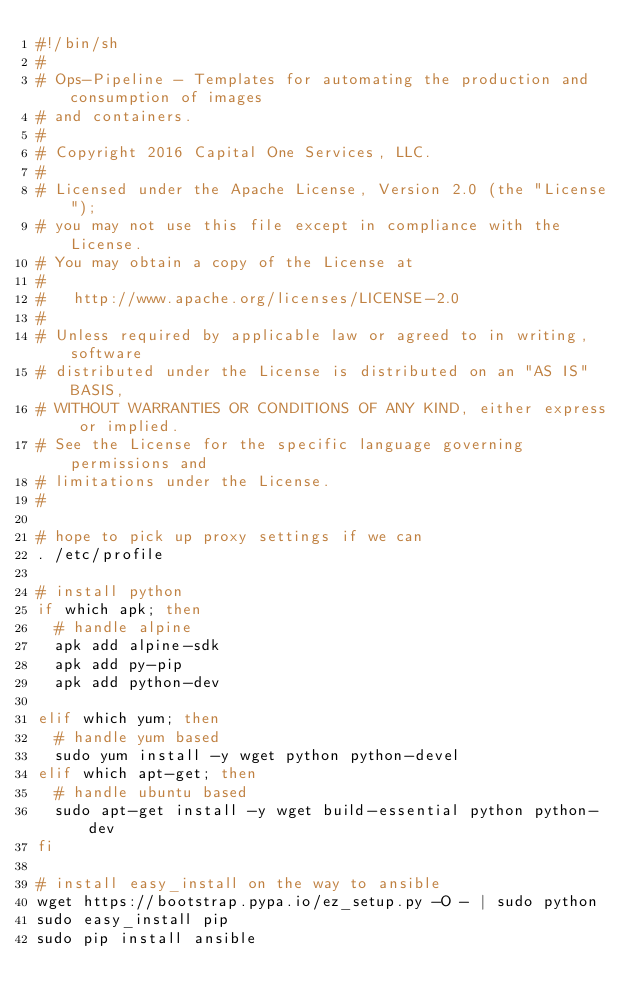<code> <loc_0><loc_0><loc_500><loc_500><_Bash_>#!/bin/sh
#
# Ops-Pipeline - Templates for automating the production and consumption of images
# and containers.
#
# Copyright 2016 Capital One Services, LLC.
#
# Licensed under the Apache License, Version 2.0 (the "License");
# you may not use this file except in compliance with the License.
# You may obtain a copy of the License at
#
#   http://www.apache.org/licenses/LICENSE-2.0
#
# Unless required by applicable law or agreed to in writing, software
# distributed under the License is distributed on an "AS IS" BASIS,
# WITHOUT WARRANTIES OR CONDITIONS OF ANY KIND, either express or implied.
# See the License for the specific language governing permissions and
# limitations under the License.
#

# hope to pick up proxy settings if we can
. /etc/profile

# install python
if which apk; then
	# handle alpine
	apk add alpine-sdk
	apk add py-pip
	apk add python-dev

elif which yum; then
	# handle yum based
	sudo yum install -y wget python python-devel
elif which apt-get; then
	# handle ubuntu based
	sudo apt-get install -y wget build-essential python python-dev
fi

# install easy_install on the way to ansible
wget https://bootstrap.pypa.io/ez_setup.py -O - | sudo python
sudo easy_install pip
sudo pip install ansible</code> 